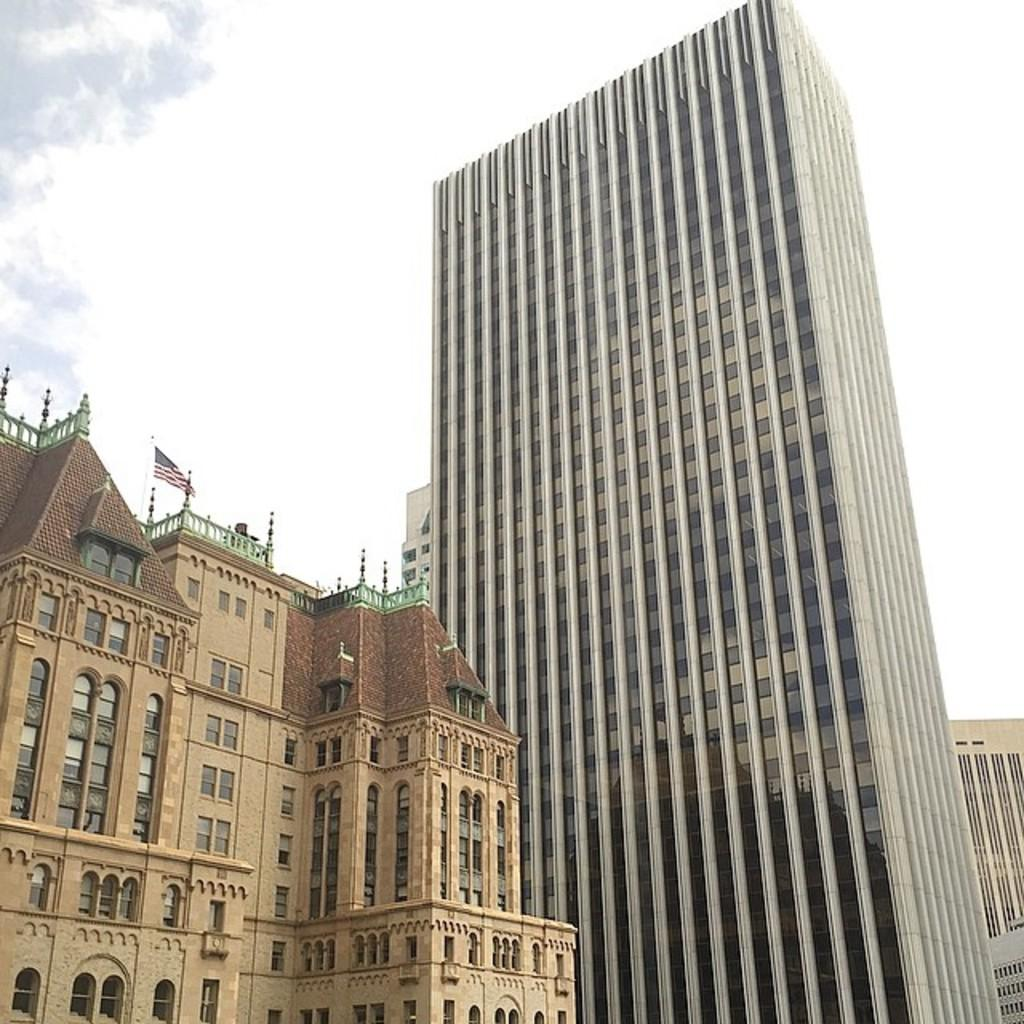What type of structures are present in the image? There are buildings in the image. What feature can be seen on the buildings? The buildings have windows. What national symbol is visible in the image? There is a flag of a country in the image. How would you describe the weather based on the image? The sky is cloudy in the image. What type of chess piece is depicted on the flag in the image? There is no chess piece depicted on the flag in the image; it is a national symbol of a country. How many potatoes can be seen in the image? There are no potatoes present in the image. 